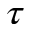<formula> <loc_0><loc_0><loc_500><loc_500>\tau</formula> 